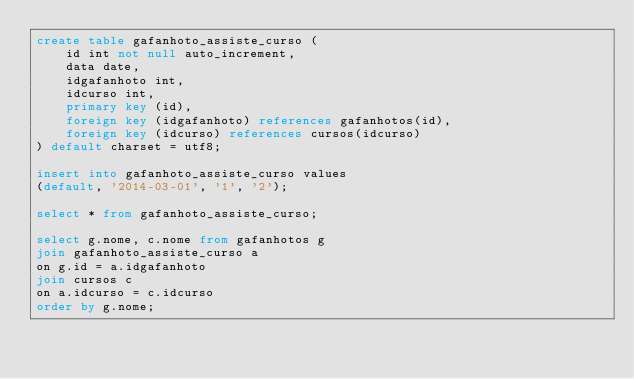Convert code to text. <code><loc_0><loc_0><loc_500><loc_500><_SQL_>create table gafanhoto_assiste_curso (
	id int not null auto_increment,
	data date,
	idgafanhoto int,
	idcurso int,
	primary key (id),
	foreign key (idgafanhoto) references gafanhotos(id),
	foreign key (idcurso) references cursos(idcurso)
) default charset = utf8;

insert into gafanhoto_assiste_curso values
(default, '2014-03-01', '1', '2');

select * from gafanhoto_assiste_curso;

select g.nome, c.nome from gafanhotos g
join gafanhoto_assiste_curso a
on g.id = a.idgafanhoto
join cursos c
on a.idcurso = c.idcurso
order by g.nome;</code> 